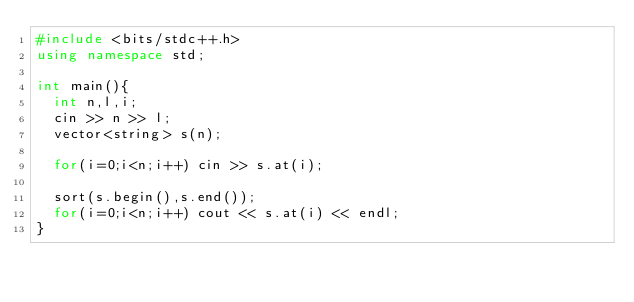Convert code to text. <code><loc_0><loc_0><loc_500><loc_500><_C++_>#include <bits/stdc++.h>
using namespace std;
       
int main(){
  int n,l,i;        
  cin >> n >> l;
  vector<string> s(n);
  
  for(i=0;i<n;i++) cin >> s.at(i);
        
  sort(s.begin(),s.end());
  for(i=0;i<n;i++) cout << s.at(i) << endl;
}</code> 